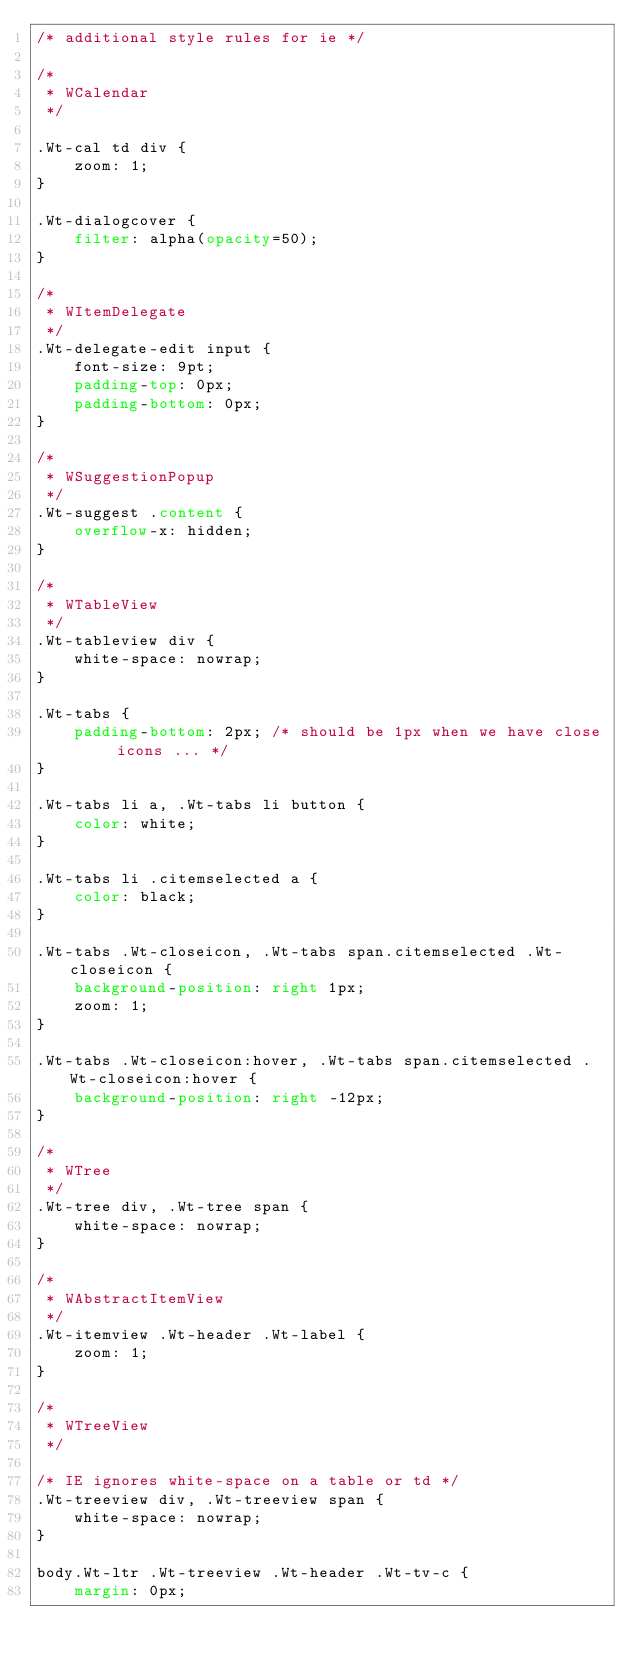<code> <loc_0><loc_0><loc_500><loc_500><_CSS_>/* additional style rules for ie */

/*
 * WCalendar
 */

.Wt-cal td div {
    zoom: 1;
}

.Wt-dialogcover {
    filter: alpha(opacity=50);
}

/*
 * WItemDelegate
 */
.Wt-delegate-edit input {
    font-size: 9pt;
    padding-top: 0px;
    padding-bottom: 0px;
}

/*
 * WSuggestionPopup
 */
.Wt-suggest .content {
    overflow-x: hidden;
}

/*
 * WTableView
 */
.Wt-tableview div {
    white-space: nowrap;
}

.Wt-tabs {
    padding-bottom: 2px; /* should be 1px when we have close icons ... */
}

.Wt-tabs li a, .Wt-tabs li button {
    color: white;
}

.Wt-tabs li .citemselected a {
    color: black;
}

.Wt-tabs .Wt-closeicon, .Wt-tabs span.citemselected .Wt-closeicon {
    background-position: right 1px;
    zoom: 1;
}

.Wt-tabs .Wt-closeicon:hover, .Wt-tabs span.citemselected .Wt-closeicon:hover {
    background-position: right -12px;
}

/*
 * WTree
 */
.Wt-tree div, .Wt-tree span {
    white-space: nowrap;   
}

/*
 * WAbstractItemView
 */
.Wt-itemview .Wt-header .Wt-label {
    zoom: 1;
}

/*
 * WTreeView
 */

/* IE ignores white-space on a table or td */
.Wt-treeview div, .Wt-treeview span {
    white-space: nowrap;
}

body.Wt-ltr .Wt-treeview .Wt-header .Wt-tv-c {
    margin: 0px;</code> 